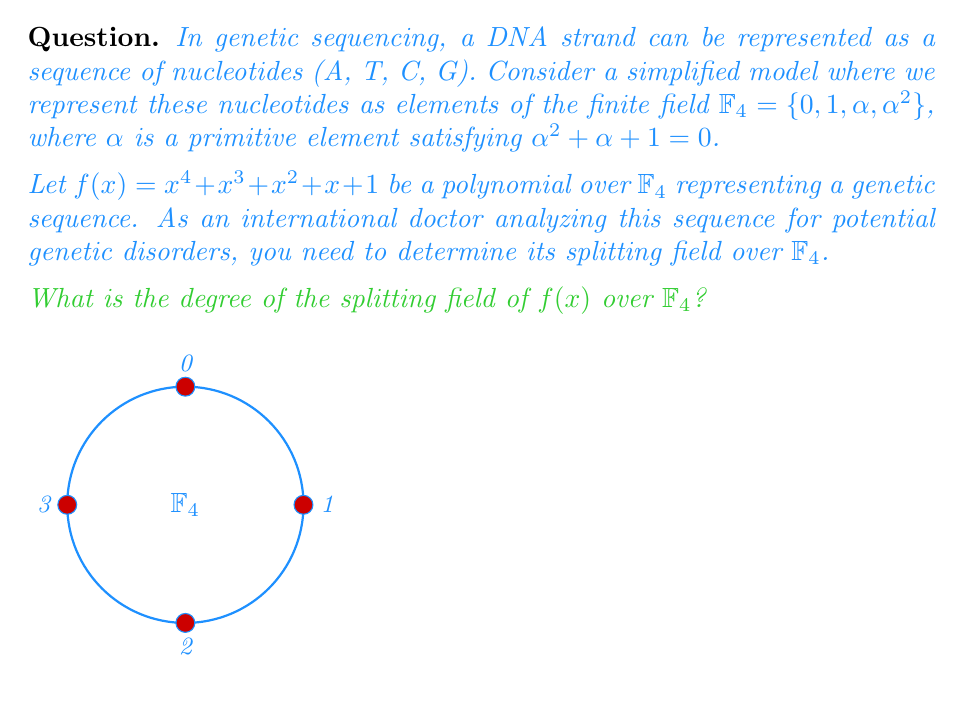Give your solution to this math problem. To solve this problem, we'll use concepts from Galois theory:

1) First, we need to determine if $f(x)$ is irreducible over $\mathbb{F}_4$. We can do this by checking if it has any roots in $\mathbb{F}_4$.

2) Evaluating $f(x)$ for each element in $\mathbb{F}_4$:
   $f(0) = 1$
   $f(1) = 1 + 1 + 1 + 1 + 1 = 1$
   $f(\alpha) = \alpha^4 + \alpha^3 + \alpha^2 + \alpha + 1 = (\alpha + 1) + \alpha^3 + \alpha^2 + \alpha + 1 = \alpha^3 + \alpha^2 + \alpha \neq 0$
   $f(\alpha^2) = (\alpha^2)^4 + (\alpha^2)^3 + (\alpha^2)^2 + \alpha^2 + 1 = \alpha^3 + 1 + \alpha + \alpha^2 + 1 = \alpha^3 + \alpha^2 + \alpha \neq 0$

3) Since $f(x)$ has no roots in $\mathbb{F}_4$, it is irreducible over $\mathbb{F}_4$.

4) The degree of $f(x)$ is 4, which is relatively prime to the characteristic of $\mathbb{F}_4$ (which is 2). Therefore, $f(x)$ is separable.

5) For an irreducible, separable polynomial of degree $n$ over a finite field $\mathbb{F}_q$, the splitting field has degree $n$ over $\mathbb{F}_q$.

6) Therefore, the splitting field of $f(x)$ over $\mathbb{F}_4$ has degree 4.

This result is significant in genetic analysis as it indicates the complexity of the genetic sequence represented by $f(x)$. A higher degree splitting field suggests a more complex genetic structure, which could be relevant for identifying potential genetic disorders or unique genetic traits.
Answer: 4 